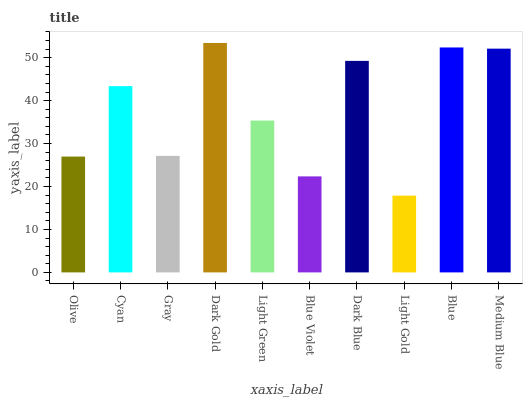Is Light Gold the minimum?
Answer yes or no. Yes. Is Dark Gold the maximum?
Answer yes or no. Yes. Is Cyan the minimum?
Answer yes or no. No. Is Cyan the maximum?
Answer yes or no. No. Is Cyan greater than Olive?
Answer yes or no. Yes. Is Olive less than Cyan?
Answer yes or no. Yes. Is Olive greater than Cyan?
Answer yes or no. No. Is Cyan less than Olive?
Answer yes or no. No. Is Cyan the high median?
Answer yes or no. Yes. Is Light Green the low median?
Answer yes or no. Yes. Is Blue Violet the high median?
Answer yes or no. No. Is Blue the low median?
Answer yes or no. No. 